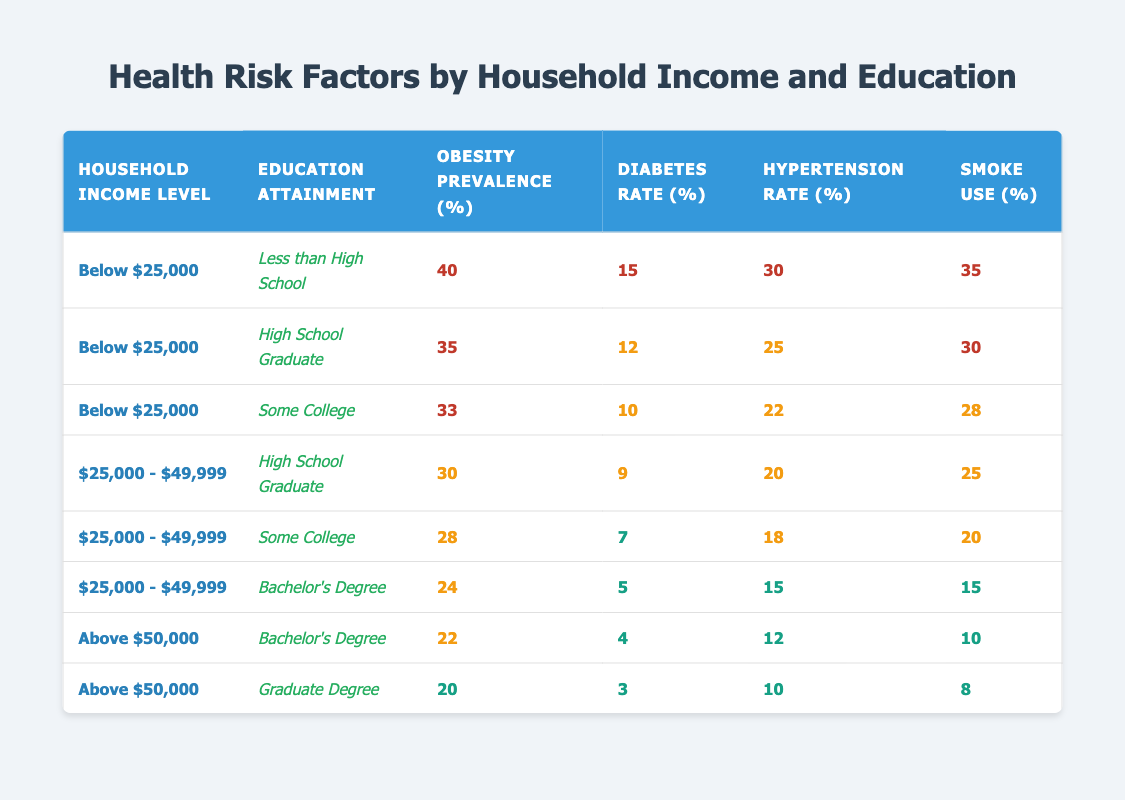What is the obesity prevalence for households earning below $25,000 with less than a high school education? Looking at the table, the specific row for "Below $25,000" and "Less than High School" shows an obesity prevalence of 40%.
Answer: 40 What is the diabetes rate for households with a bachelor's degree and an income of $25,000 to $49,999? The relevant row for "$25,000 - $49,999" and "Bachelor's Degree" indicates a diabetes rate of 5%.
Answer: 5 True or false: The smoke use percentage decreases as education attainment increases within the income level of "$25,000 - $49,999". Reviewing the rows for "$25,000 - $49,999", we see that smoke use is 25% for high school graduates, 20% for those with some college, and 15% for bachelor's degree holders. This confirms a decreasing trend.
Answer: True What is the average hypertension rate of all groups within households earning below $25,000? First, identify the hypertension rates for all groups under "$25,000": 30 (Less than High School), 25 (High School Graduate), 22 (Some College). Summing these gives 77, and dividing by 3 gives an average of 25.67.
Answer: 25.67 Which income level experiences the highest obesity prevalence? By comparing the obesity prevalence across all household income levels, the highest value of 40% is found in the "Below $25,000" category with "Less than High School" education.
Answer: Below $25,000 What is the difference in diabetes rate between high school graduates with incomes below $25,000 and those with incomes above $50,000 with a bachelor's degree? The diabetes rate for high school graduates below $25,000 is 12%, while for those above $50,000 with a bachelor's degree, it is 4%. The difference is 12 - 4 = 8%.
Answer: 8% How many individuals in the "Some College" category are smokers if they earn between $25,000 and $49,999? According to the table, the smoke use percentage for this group is 20%. This indicates that 20% of this demographic are reported as smokers.
Answer: 20% Is it true that households earning above $50,000 and holding a graduate degree have the lowest hypertension rate? Checking the row for those earning above $50,000 with a graduate degree, the hypertension rate is 10%, which is lower than any other groups listed. This confirms that they indeed have the lowest hypertension rate.
Answer: True 